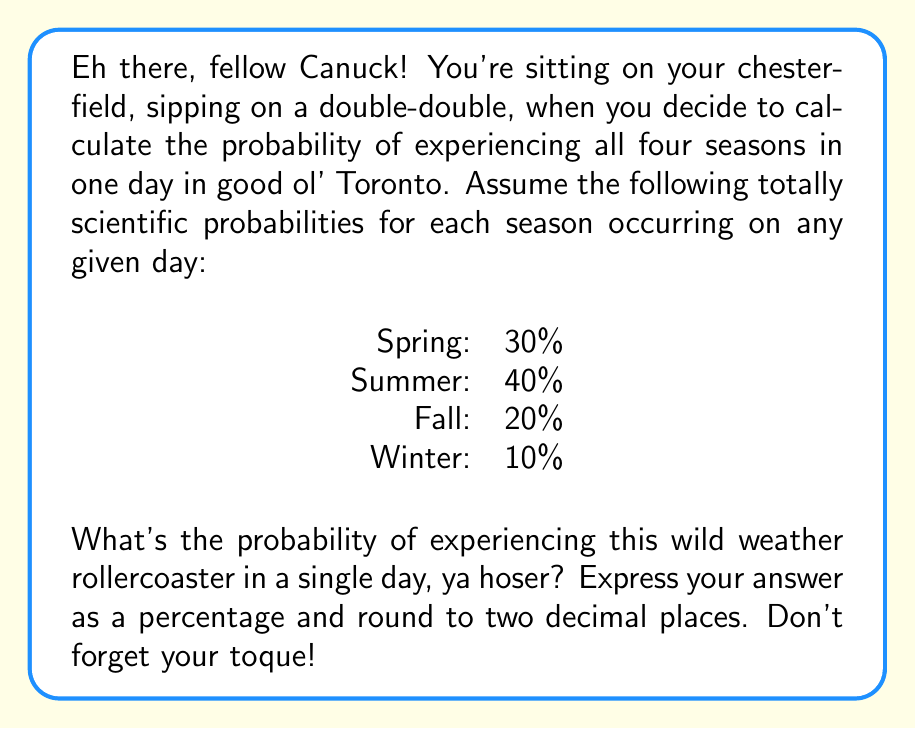Give your solution to this math problem. Alright, let's break this down like we're dissecting a Nanaimo bar, shall we?

1) First, we need to recognize that this is a problem of independent events occurring together. Each season's occurrence is independent of the others.

2) To calculate the probability of all these independent events occurring together, we multiply their individual probabilities.

3) Let's express our probabilities as decimals:
   Spring: $0.30$
   Summer: $0.40$
   Fall: $0.20$
   Winter: $0.10$

4) Now, we multiply these probabilities:

   $$P(\text{All seasons}) = 0.30 \times 0.40 \times 0.20 \times 0.10$$

5) Let's crunch those numbers:

   $$P(\text{All seasons}) = 0.0024$$

6) To express this as a percentage, we multiply by 100:

   $$0.0024 \times 100 = 0.24\%$$

7) Rounding to two decimal places (which doesn't change our result in this case):

   $$0.24\%$$

And there you have it, as rare as finding a parking spot during a Leafs game!
Answer: 0.24% 